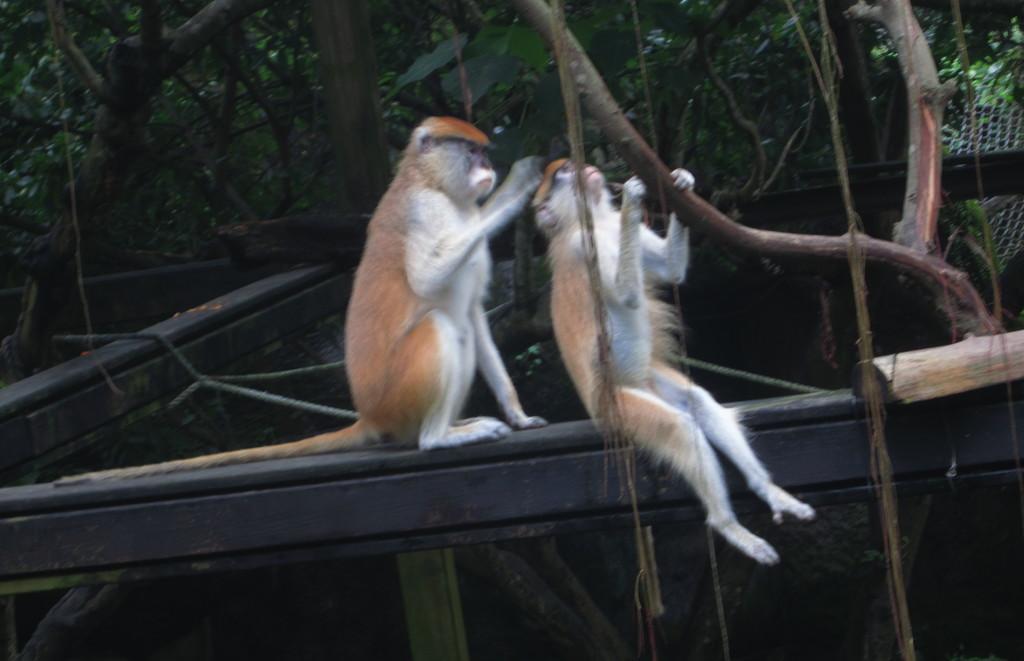How would you summarize this image in a sentence or two? In this image we can see monkeys, wooden poles, mesh, and branches. 